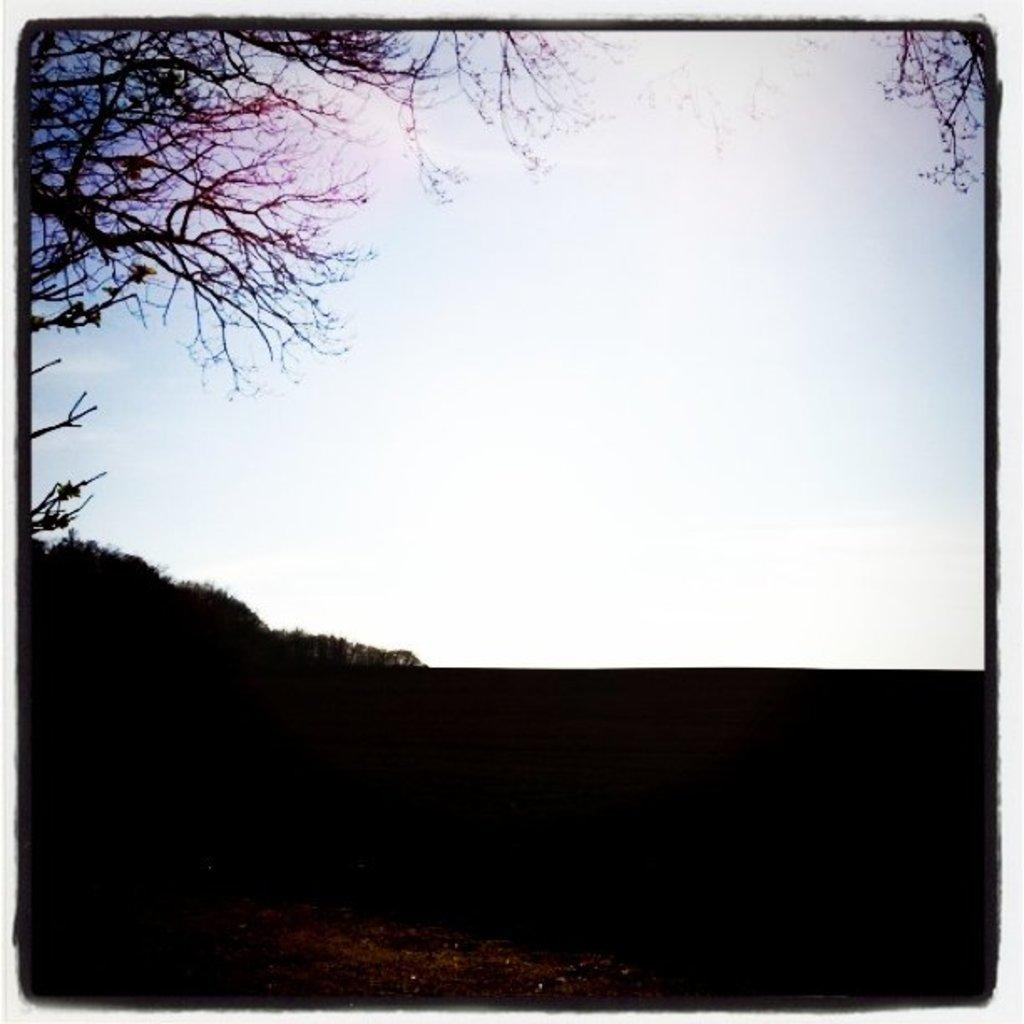What type of vegetation can be seen in the image? There are trees in the image. What part of the natural environment is visible in the image? The sky is visible in the image. How would you describe the lighting in the image? The image is dark. How many robins can be seen perched on the trees in the image? There are no robins present in the image; it only features trees and a dark sky. What type of stem is visible in the image? There is no stem present in the image. 